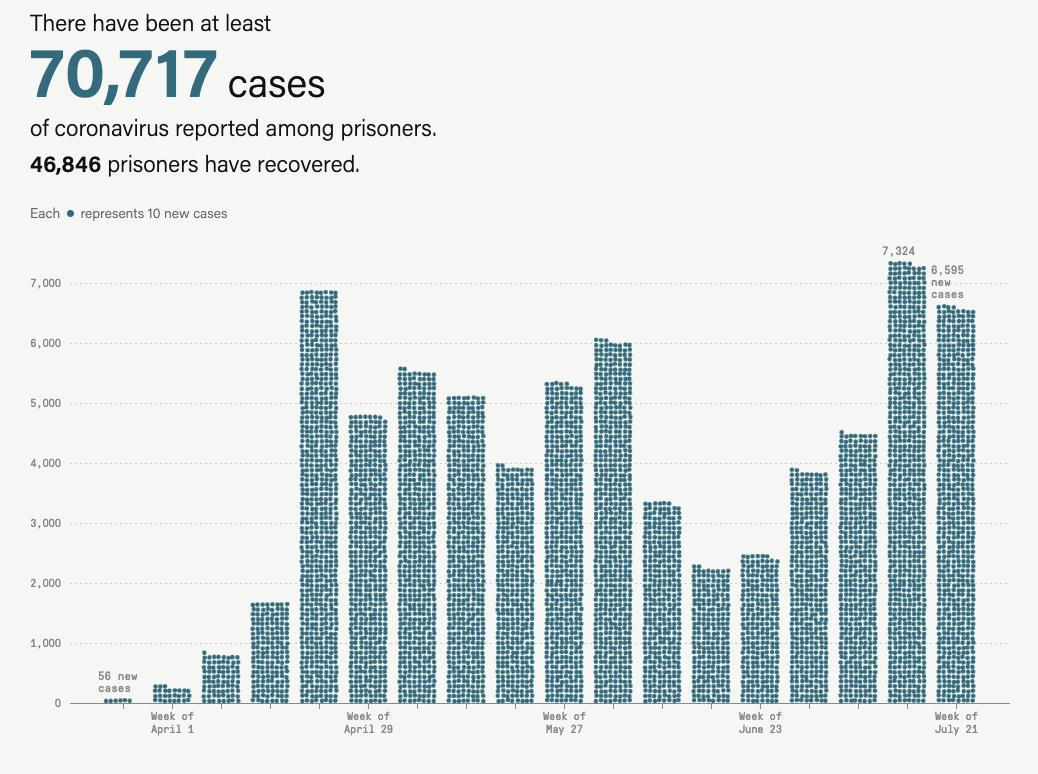which month was the third highest cases reported
Answer the question with a short phrase. July which month was second highest cases reported April which month was the highest number of cases reported July How many prisoners have not recovered or yet to recover 23871 